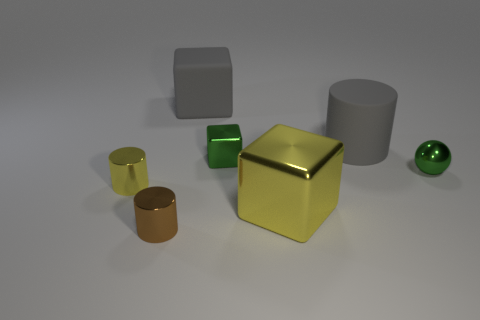The object that is the same material as the gray cube is what color?
Make the answer very short. Gray. Are there fewer brown things than metallic things?
Give a very brief answer. Yes. There is a cylinder that is behind the tiny green object on the right side of the big object that is in front of the tiny metal ball; what is its material?
Ensure brevity in your answer.  Rubber. What material is the brown thing?
Give a very brief answer. Metal. There is a large object that is in front of the matte cylinder; does it have the same color as the metal object to the left of the brown shiny thing?
Provide a short and direct response. Yes. Is the number of yellow blocks greater than the number of big cyan metal blocks?
Give a very brief answer. Yes. How many big matte things are the same color as the large metal cube?
Your answer should be compact. 0. What color is the big matte thing that is the same shape as the brown shiny thing?
Provide a succinct answer. Gray. There is a object that is on the right side of the big rubber cube and in front of the metal ball; what material is it made of?
Keep it short and to the point. Metal. Is the material of the green thing left of the ball the same as the cylinder that is behind the tiny green shiny ball?
Make the answer very short. No. 